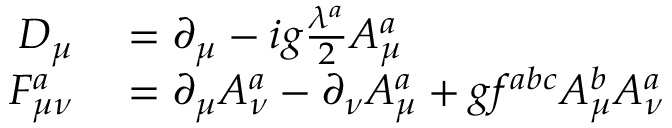<formula> <loc_0><loc_0><loc_500><loc_500>\begin{array} { r l } { D _ { \mu } } & = \partial _ { \mu } - i g \frac { \lambda ^ { a } } { 2 } A _ { \mu } ^ { a } } \\ { F _ { \mu \nu } ^ { a } } & = \partial _ { \mu } A _ { \nu } ^ { a } - \partial _ { \nu } A _ { \mu } ^ { a } + g f ^ { a b c } A _ { \mu } ^ { b } A _ { \nu } ^ { a } } \end{array}</formula> 